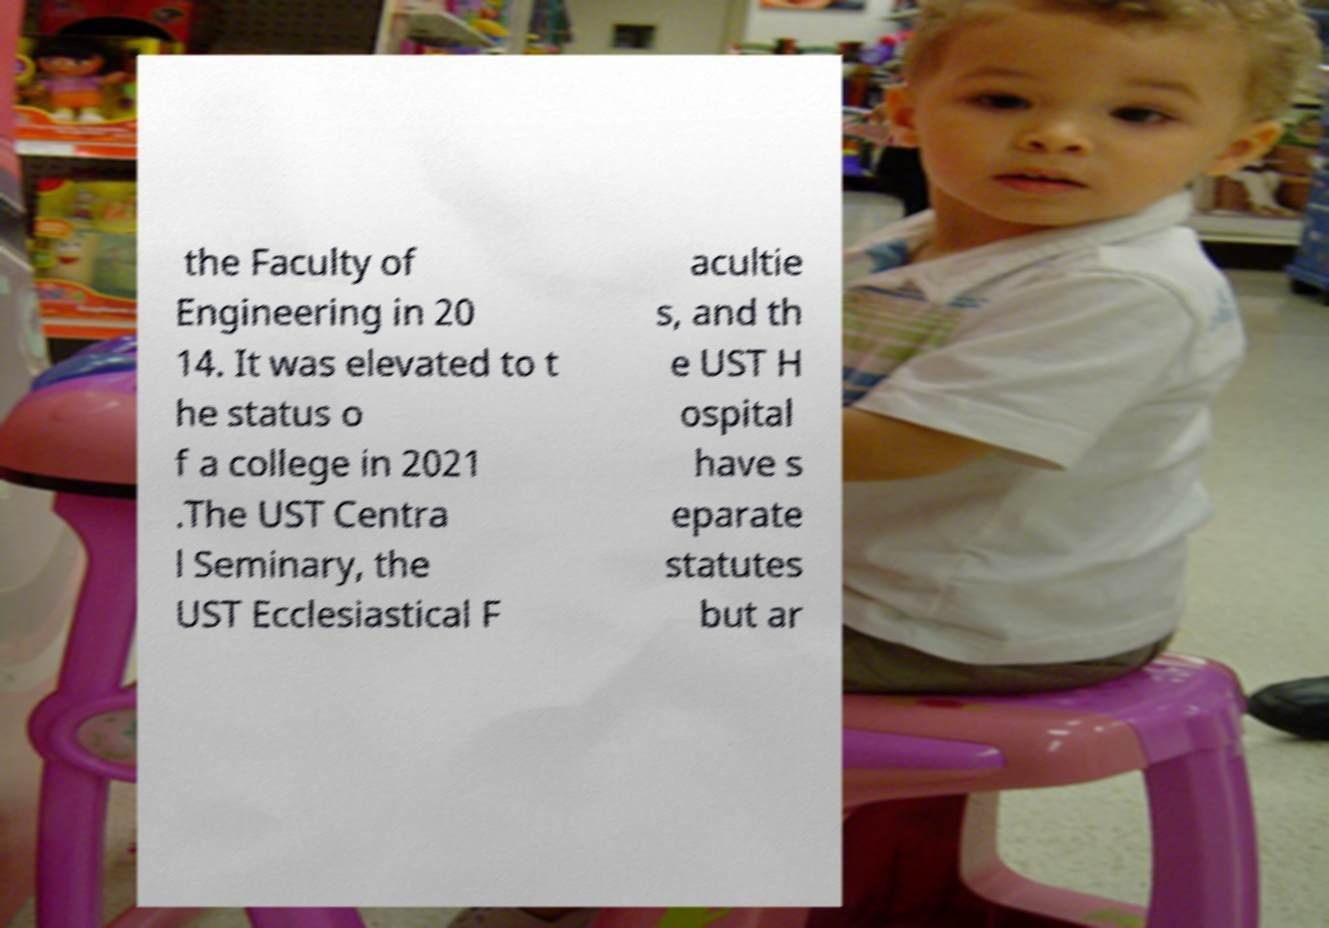For documentation purposes, I need the text within this image transcribed. Could you provide that? the Faculty of Engineering in 20 14. It was elevated to t he status o f a college in 2021 .The UST Centra l Seminary, the UST Ecclesiastical F acultie s, and th e UST H ospital have s eparate statutes but ar 